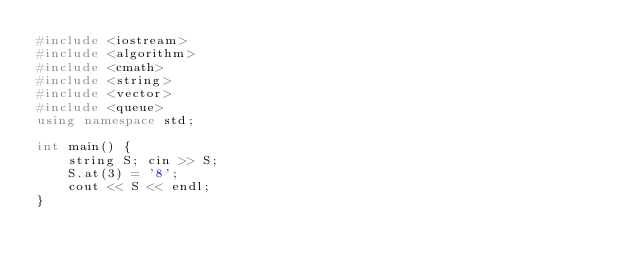Convert code to text. <code><loc_0><loc_0><loc_500><loc_500><_C++_>#include <iostream>
#include <algorithm>
#include <cmath>
#include <string>
#include <vector>
#include <queue>
using namespace std;

int main() {
	string S; cin >> S;
	S.at(3) = '8';
	cout << S << endl;
}</code> 